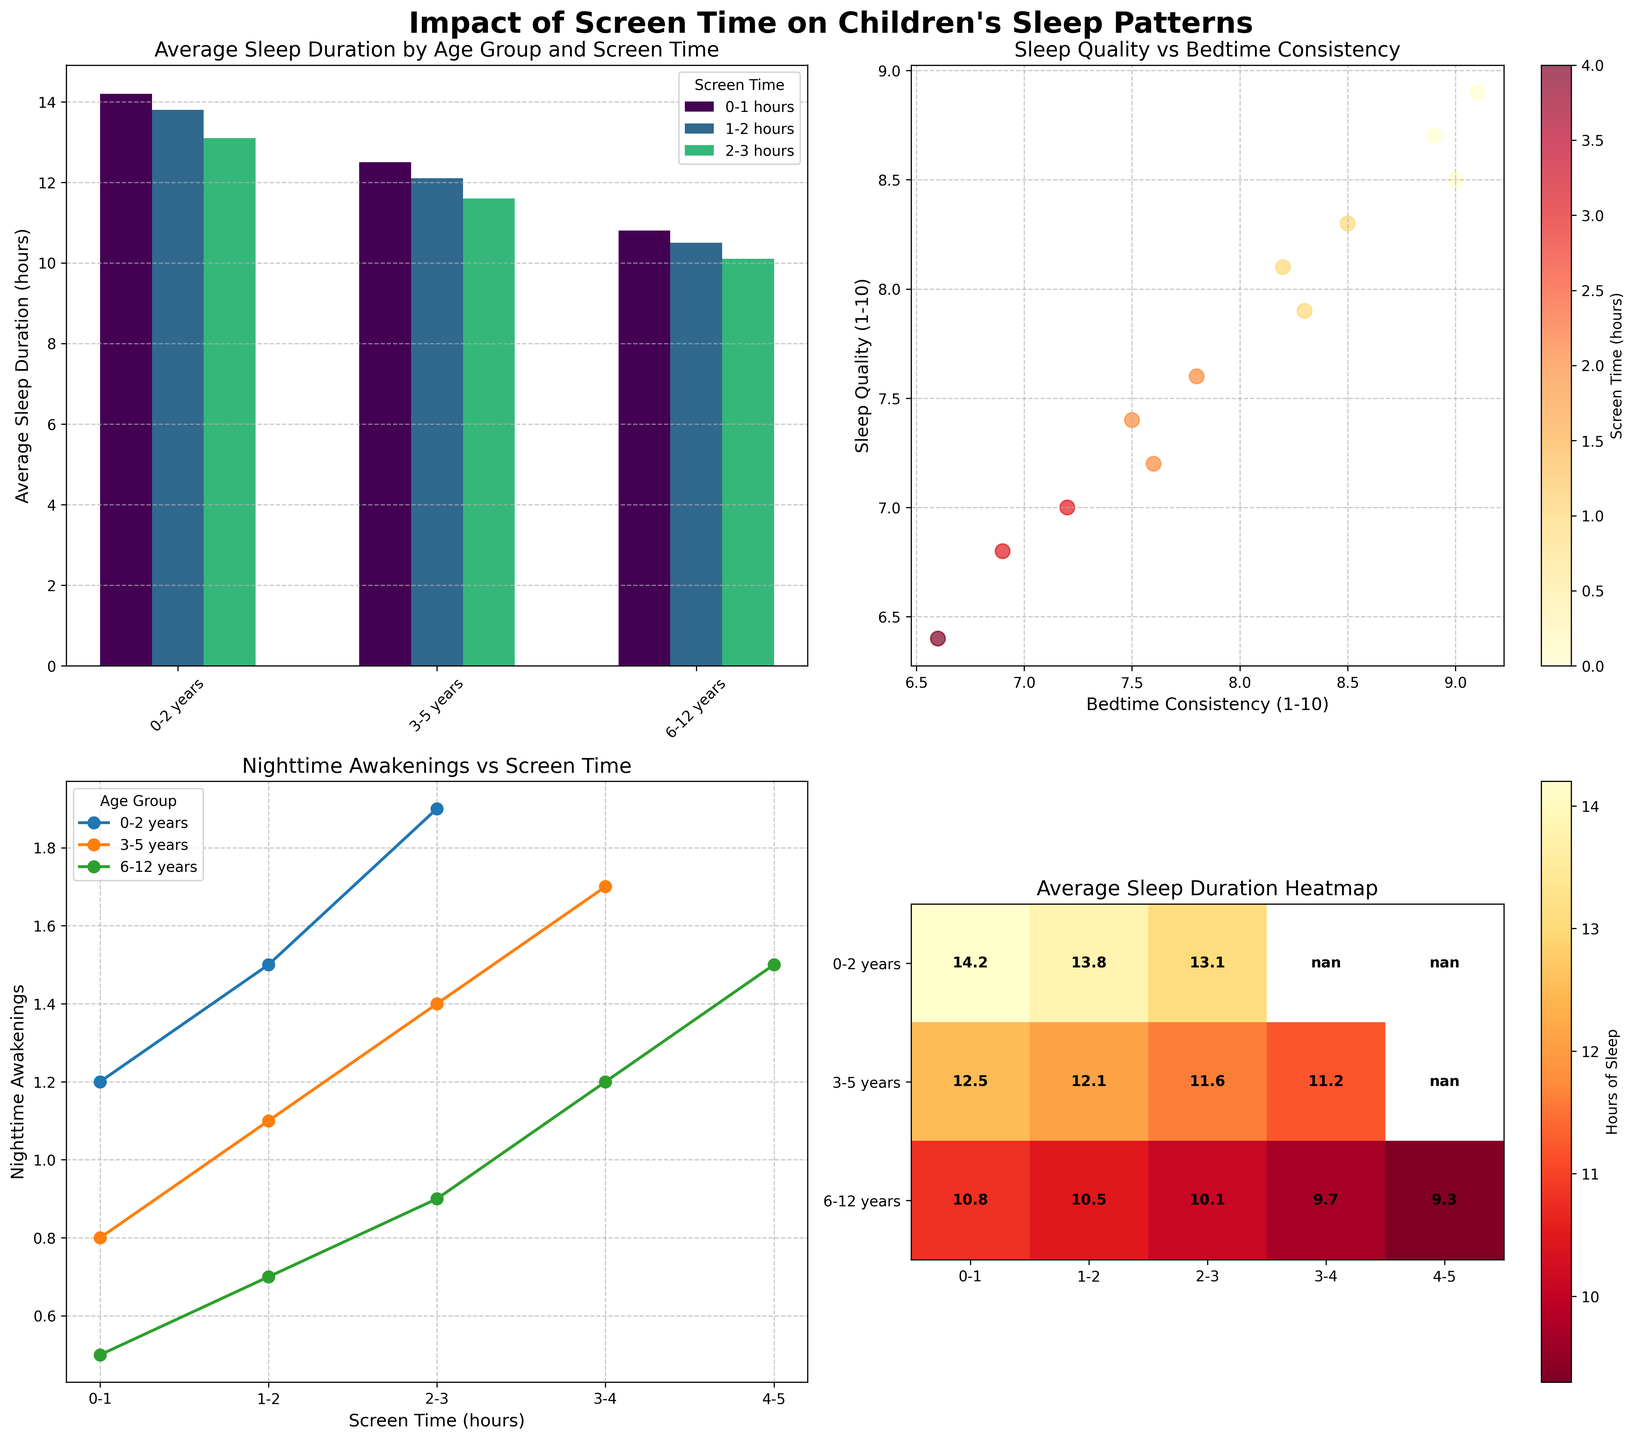What is the average sleep duration for the 3-5 years age group with 2-3 hours of screen time? Locate the bar corresponding to the 3-5 years age group and the 2-3 hours screen time in the bar chart. The height of this bar gives the average sleep duration.
Answer: 11.6 hours How does sleep quality vary with bedtime consistency across different screen times? Analyze the scatter plot showing the relationship between sleep quality and bedtime consistency. Each point's color indicates different screen times based on the color bar legend.
Answer: Higher bedtime consistency generally correlates with higher sleep quality Which age group experiences the most nighttime awakenings when exposed to 3-4 hours of screen time? Refer to the line plot where nighttime awakenings are plotted against screen time for different age groups. Identify the line for the 3-4 hours screen time period and find the highest point.
Answer: 6-12 years How does the sleep quality for children aged 0-2 years with 1-2 hours of screen time compare to those with 2-3 hours? Refer to the scatter plot to locate the points for 0-2 years with 1-2 and 2-3 hours of screen time and compare their vertical positions, which represent sleep quality.
Answer: Sleep quality decreases from 7.9 to 7.2 What is the average sleep duration for the 6-12 years age group across all screen times based on the heatmap? Use the heatmap which shows the average sleep duration. Read the values for the 6-12 years row and calculate their average.
Answer: (10.8 + 10.5 + 10.1 + 9.7 + 9.3) / 5 = 10.08 hours 